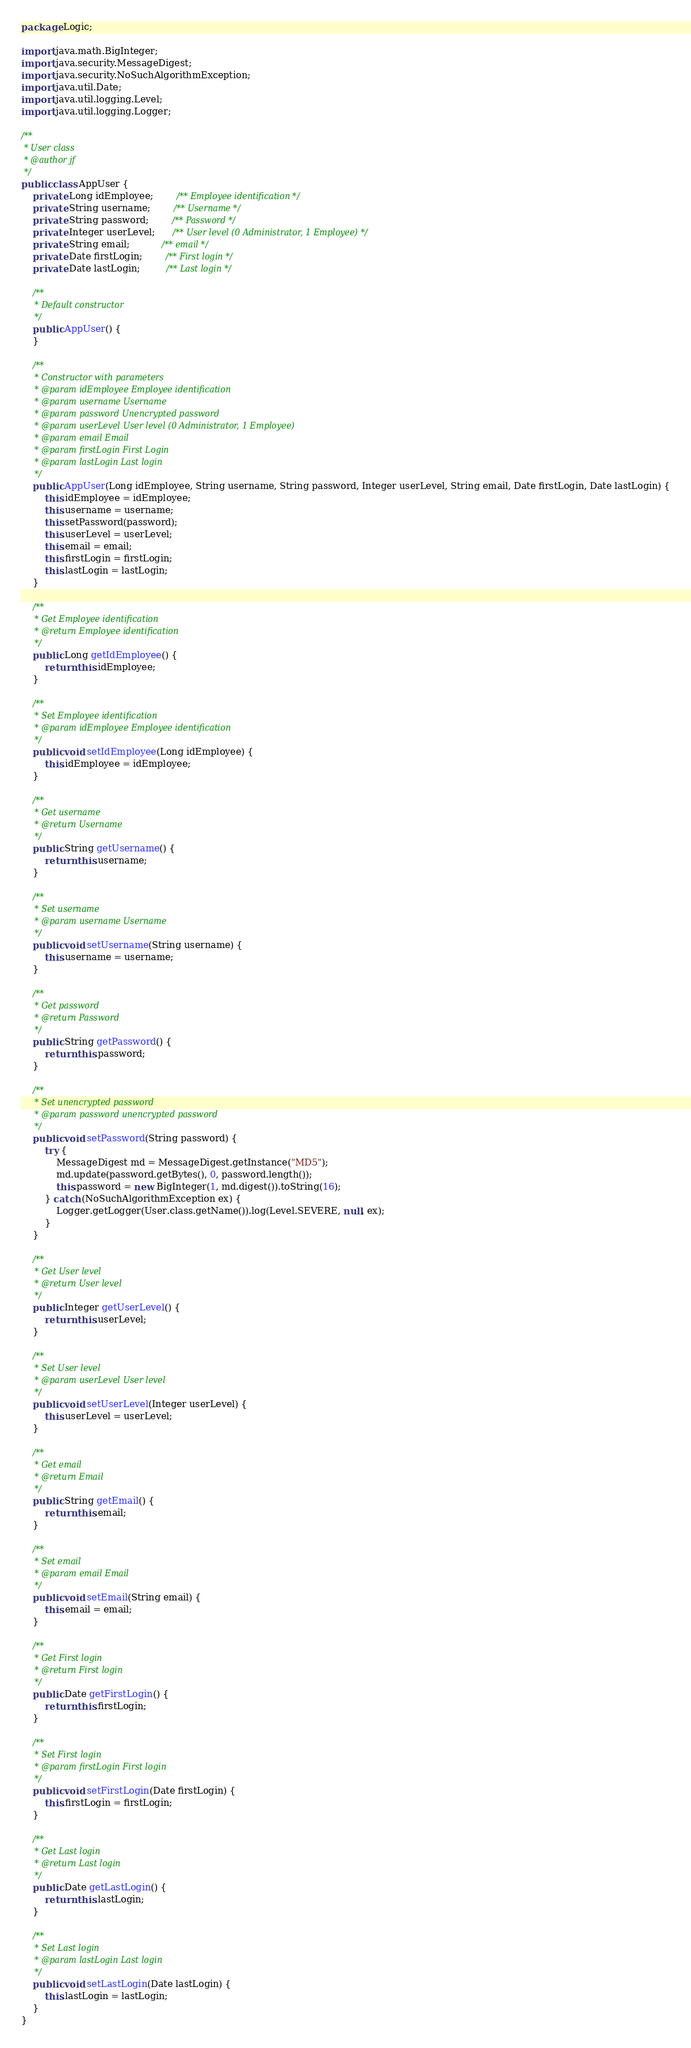Convert code to text. <code><loc_0><loc_0><loc_500><loc_500><_Java_>package Logic;

import java.math.BigInteger;
import java.security.MessageDigest;
import java.security.NoSuchAlgorithmException;
import java.util.Date;
import java.util.logging.Level;
import java.util.logging.Logger;

/**
 * User class
 * @author jf
 */
public class AppUser {
    private Long idEmployee;        /** Employee identification */
    private String username;        /** Username */
    private String password;        /** Password */
    private Integer userLevel;      /** User level (0 Administrator, 1 Employee) */
    private String email;           /** email */
    private Date firstLogin;        /** First login */
    private Date lastLogin;         /** Last login */

    /**
     * Default constructor
     */
    public AppUser() {
    }

    /**
     * Constructor with parameters
     * @param idEmployee Employee identification 
     * @param username Username
     * @param password Unencrypted password
     * @param userLevel User level (0 Administrator, 1 Employee)
     * @param email Email
     * @param firstLogin First Login
     * @param lastLogin Last login
     */
    public AppUser(Long idEmployee, String username, String password, Integer userLevel, String email, Date firstLogin, Date lastLogin) {
        this.idEmployee = idEmployee;
        this.username = username;
        this.setPassword(password);
        this.userLevel = userLevel;
        this.email = email;
        this.firstLogin = firstLogin;
        this.lastLogin = lastLogin;
    }

    /**
     * Get Employee identification
     * @return Employee identification
     */
    public Long getIdEmployee() {
        return this.idEmployee;
    }

    /**
     * Set Employee identification
     * @param idEmployee Employee identification
     */
    public void setIdEmployee(Long idEmployee) {
        this.idEmployee = idEmployee;
    }

    /**
     * Get username
     * @return Username
     */
    public String getUsername() {
        return this.username;
    }

    /**
     * Set username
     * @param username Username
     */
    public void setUsername(String username) {
        this.username = username;
    }

    /**
     * Get password
     * @return Password
     */
    public String getPassword() {
        return this.password;
    }

    /**
     * Set unencrypted password
     * @param password unencrypted password
     */
    public void setPassword(String password) {
        try {
            MessageDigest md = MessageDigest.getInstance("MD5");
            md.update(password.getBytes(), 0, password.length());
            this.password = new BigInteger(1, md.digest()).toString(16);
        } catch (NoSuchAlgorithmException ex) {
            Logger.getLogger(User.class.getName()).log(Level.SEVERE, null, ex);
        }
    }

    /**
     * Get User level
     * @return User level
     */
    public Integer getUserLevel() {
        return this.userLevel;
    }

    /**
     * Set User level
     * @param userLevel User level
     */
    public void setUserLevel(Integer userLevel) {
        this.userLevel = userLevel;
    }

    /**
     * Get email
     * @return Email
     */
    public String getEmail() {
        return this.email;
    }

    /**
     * Set email
     * @param email Email
     */
    public void setEmail(String email) {
        this.email = email;
    }

    /**
     * Get First login
     * @return First login
     */
    public Date getFirstLogin() {
        return this.firstLogin;
    }

    /**
     * Set First login
     * @param firstLogin First login
     */
    public void setFirstLogin(Date firstLogin) {
        this.firstLogin = firstLogin;
    }

    /**
     * Get Last login
     * @return Last login
     */
    public Date getLastLogin() {
        return this.lastLogin;
    }

    /**
     * Set Last login
     * @param lastLogin Last login
     */
    public void setLastLogin(Date lastLogin) {
        this.lastLogin = lastLogin;
    }
}
</code> 